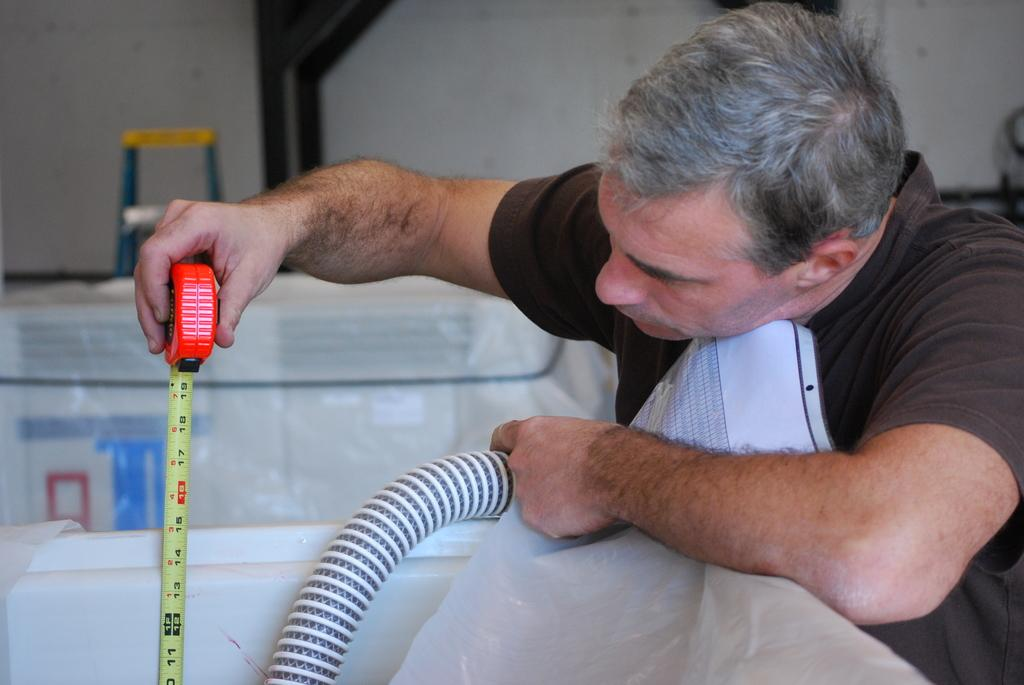What is the man doing on the right side of the image? The man is checking the height with a tape in his hand. What is the man wearing in the image? The man is wearing a t-shirt. What type of faucet is visible in the image? There is no faucet present in the image. What color is the man's skin in the image? The provided facts do not mention the color of the man's skin, so it cannot be determined from the image. 